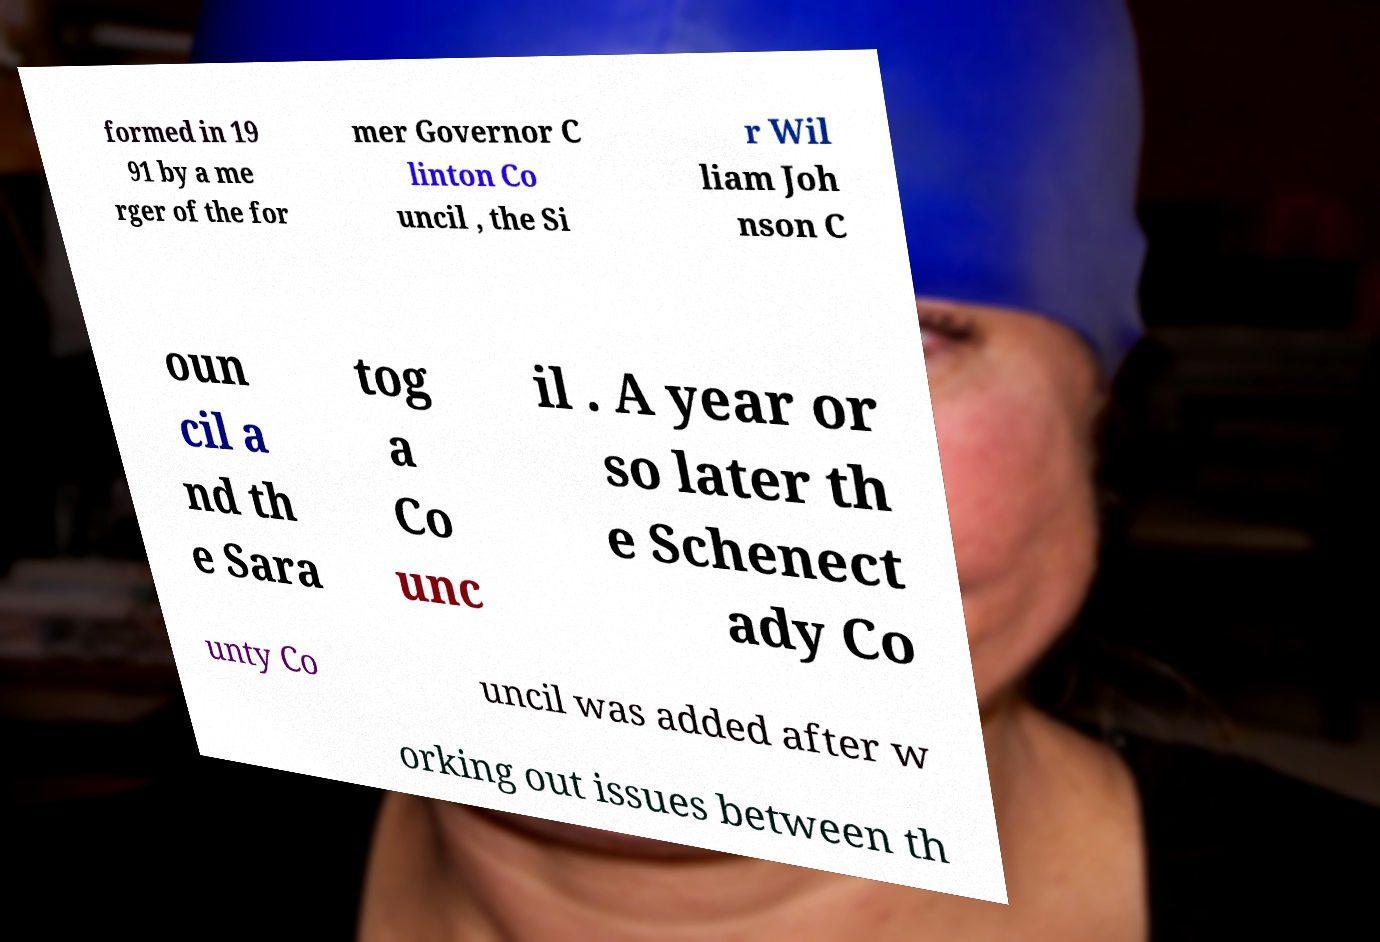For documentation purposes, I need the text within this image transcribed. Could you provide that? formed in 19 91 by a me rger of the for mer Governor C linton Co uncil , the Si r Wil liam Joh nson C oun cil a nd th e Sara tog a Co unc il . A year or so later th e Schenect ady Co unty Co uncil was added after w orking out issues between th 